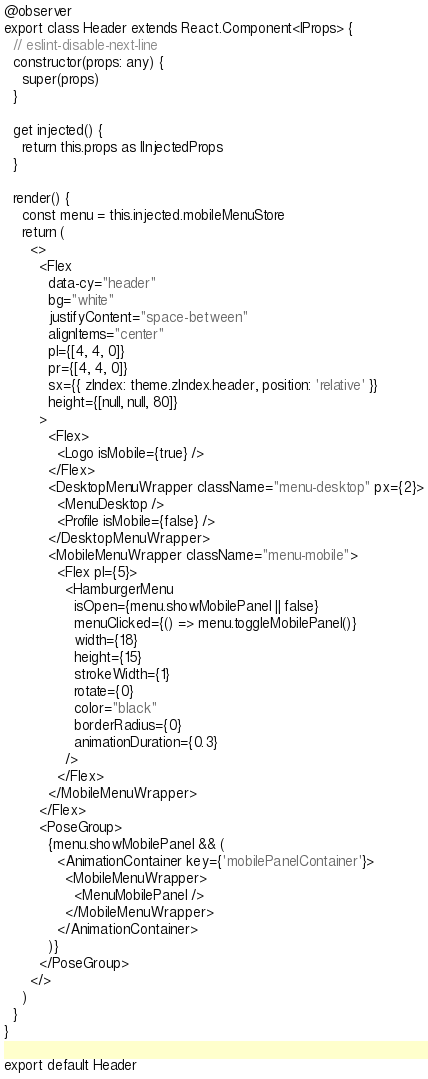Convert code to text. <code><loc_0><loc_0><loc_500><loc_500><_TypeScript_>@observer
export class Header extends React.Component<IProps> {
  // eslint-disable-next-line
  constructor(props: any) {
    super(props)
  }

  get injected() {
    return this.props as IInjectedProps
  }

  render() {
    const menu = this.injected.mobileMenuStore
    return (
      <>
        <Flex
          data-cy="header"
          bg="white"
          justifyContent="space-between"
          alignItems="center"
          pl={[4, 4, 0]}
          pr={[4, 4, 0]}
          sx={{ zIndex: theme.zIndex.header, position: 'relative' }}
          height={[null, null, 80]}
        >
          <Flex>
            <Logo isMobile={true} />
          </Flex>
          <DesktopMenuWrapper className="menu-desktop" px={2}>
            <MenuDesktop />
            <Profile isMobile={false} />
          </DesktopMenuWrapper>
          <MobileMenuWrapper className="menu-mobile">
            <Flex pl={5}>
              <HamburgerMenu
                isOpen={menu.showMobilePanel || false}
                menuClicked={() => menu.toggleMobilePanel()}
                width={18}
                height={15}
                strokeWidth={1}
                rotate={0}
                color="black"
                borderRadius={0}
                animationDuration={0.3}
              />
            </Flex>
          </MobileMenuWrapper>
        </Flex>
        <PoseGroup>
          {menu.showMobilePanel && (
            <AnimationContainer key={'mobilePanelContainer'}>
              <MobileMenuWrapper>
                <MenuMobilePanel />
              </MobileMenuWrapper>
            </AnimationContainer>
          )}
        </PoseGroup>
      </>
    )
  }
}

export default Header
</code> 